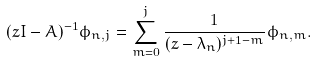Convert formula to latex. <formula><loc_0><loc_0><loc_500><loc_500>( z I - A ) ^ { - 1 } \phi _ { n , j } = \sum _ { m = 0 } ^ { j } \frac { 1 } { ( z - \lambda _ { n } ) ^ { j + 1 - m } } \phi _ { n , m } .</formula> 